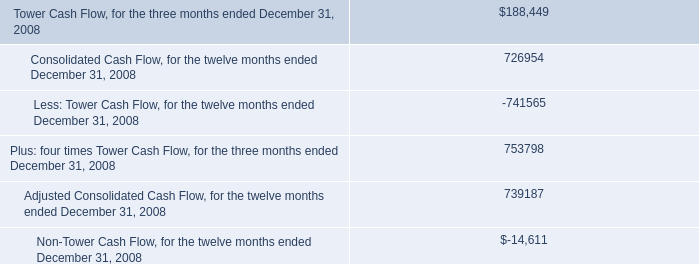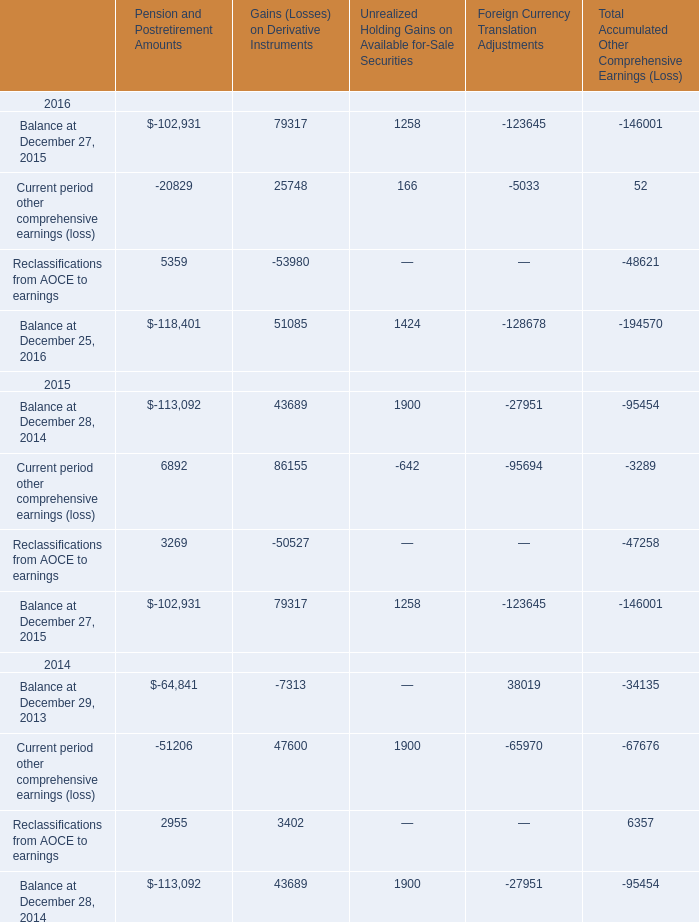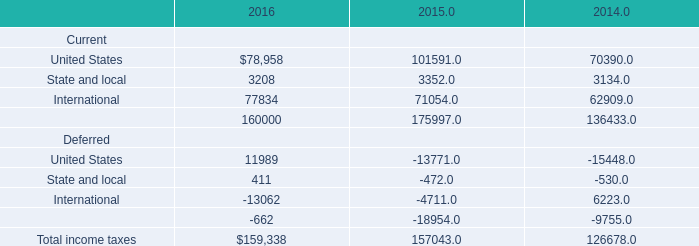Which year is Current period other comprehensive earnings (loss) in Gains (Losses) on Derivative Instruments the highest? 
Answer: 2015. 